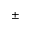<formula> <loc_0><loc_0><loc_500><loc_500>\pm</formula> 